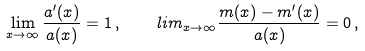<formula> <loc_0><loc_0><loc_500><loc_500>\lim _ { x \to \infty } \frac { a ^ { \prime } ( x ) } { a ( x ) } = 1 \, , \ \ \ l i m _ { x \to \infty } \frac { m ( x ) - m ^ { \prime } ( x ) } { a ( x ) } = 0 \, ,</formula> 